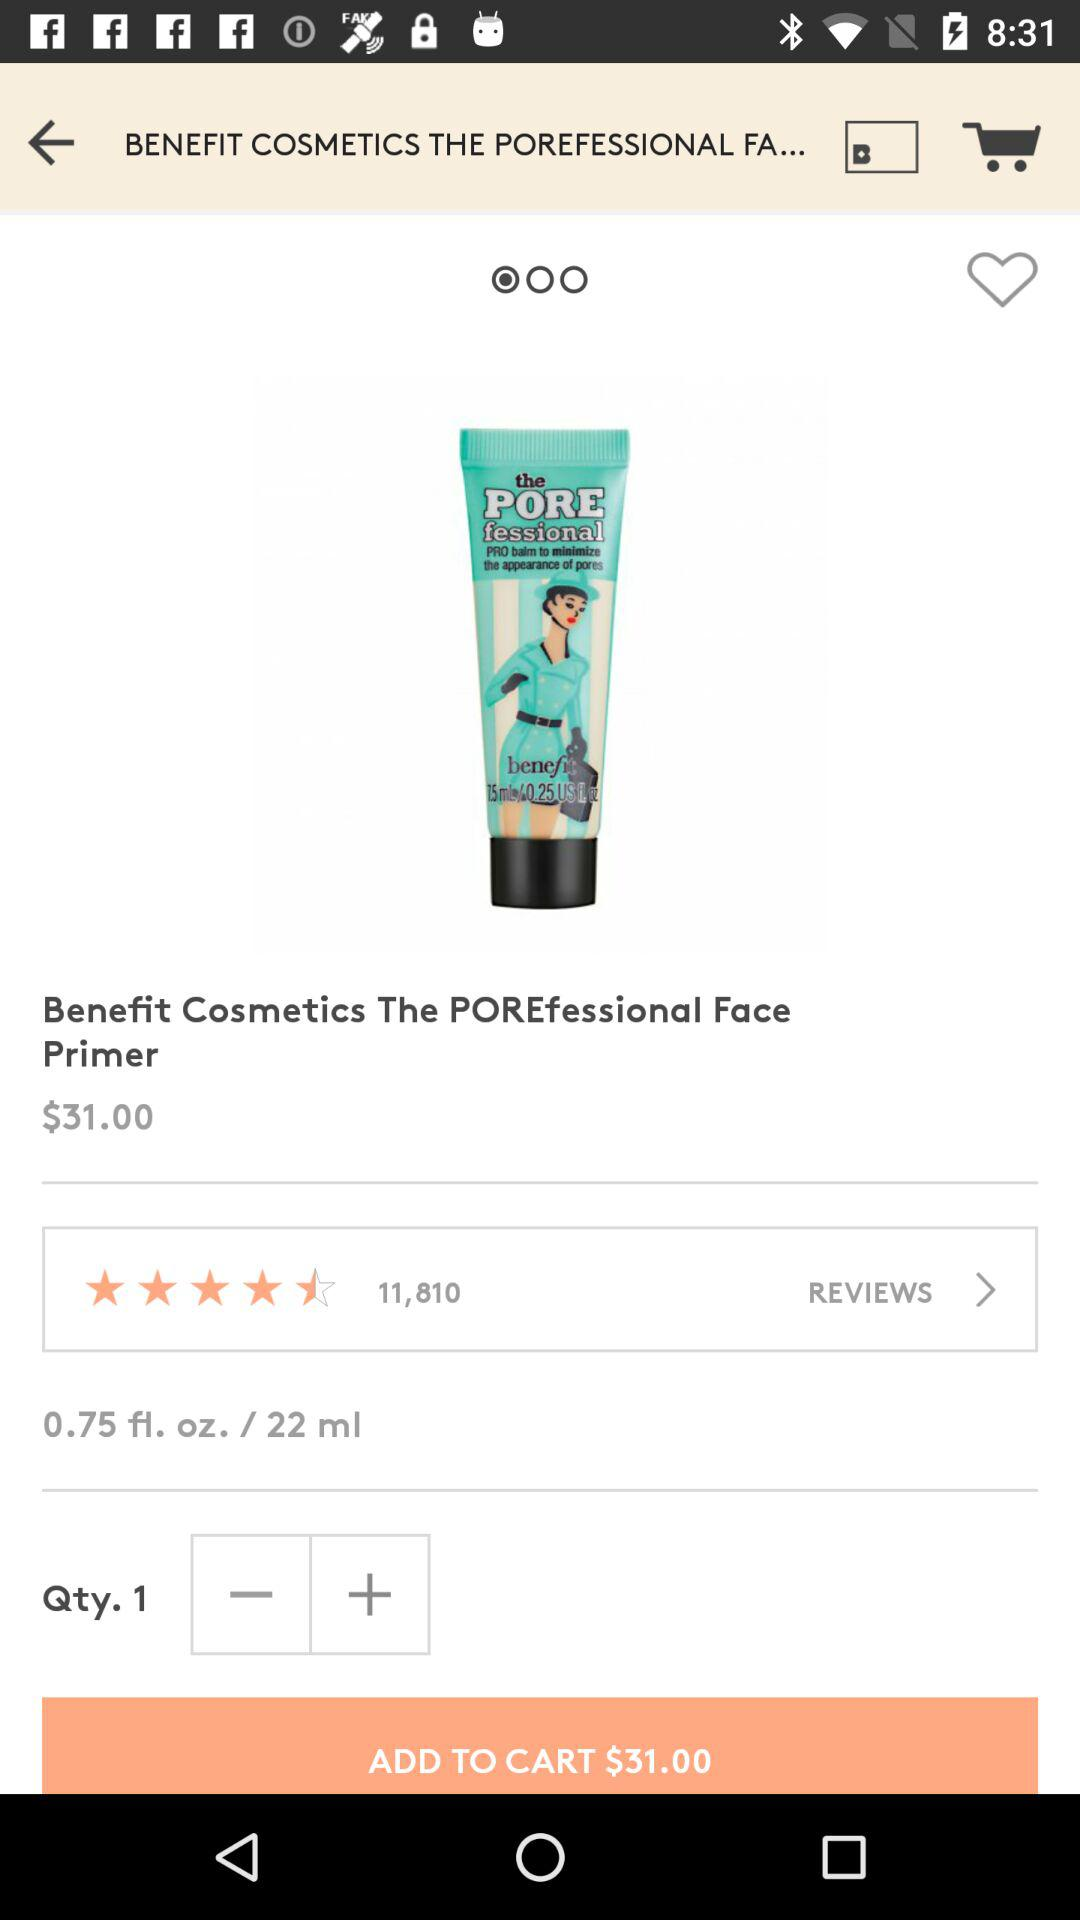What is the rating? The rating is 4.5 stars. 